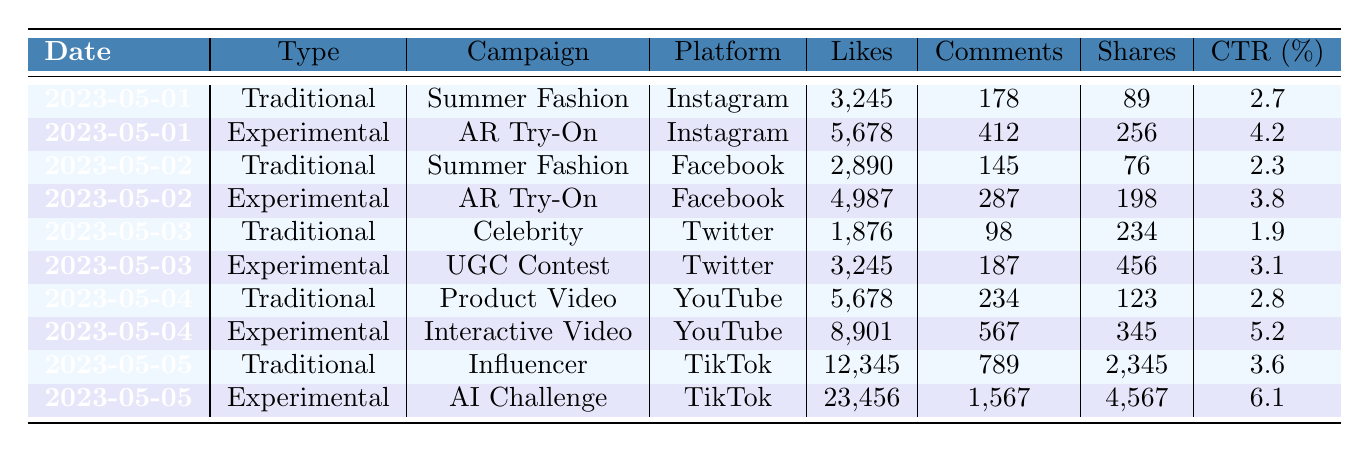What was the highest number of likes on any campaign? Looking through the likes for each campaign, the highest value is 23,456 from the campaign "AI-Generated Content Challenge" on TikTok.
Answer: 23,456 Which campaign received the most comments on May 5th? On May 5th, the "AI-Generated Content Challenge" received 1,567 comments, which is higher than any other campaign on that day.
Answer: AI-Generated Content Challenge What is the average click-through rate for traditional campaigns? The click-through rates for traditional campaigns are 2.7, 2.3, 1.9, 2.8, and 3.6. Summing these gives 13.3 and dividing by 5 gives an average of 2.66.
Answer: 2.66 Did the "Interactive Shoppable Video" campaign have a better engagement than the "Product Showcase Video"? The "Interactive Shoppable Video" had more likes (8,901 vs. 5,678), comments (567 vs. 234), shares (345 vs. 123), and a higher click-through rate (5.2% vs. 2.8%). Thus, it had better engagement.
Answer: Yes What was the total number of shares across all experimental campaigns? Adding up the shares gives 256 + 198 + 456 + 345 + 4,567 = 5,822 shares from experimental campaigns.
Answer: 5,822 Which platform had the lowest average engagement (likes + comments + shares) for traditional campaigns? For traditional campaigns, the total engagement (likes + comments + shares) on Instagram is 3,245 + 178 + 89 = 3,512; on Facebook is 2,890 + 145 + 76 = 3,111; on Twitter is 1,876 + 98 + 234 = 2,208; and on YouTube is 5,678 + 234 + 123 = 6,035. The lowest is 2,208 on Twitter.
Answer: Twitter Is there a campaign that both had the highest number of shares and the highest click-through rate? The "AI-Generated Content Challenge" had the highest shares of 4,567 and also a high click-through rate of 6.1%, making it the only campaign with both distinctions in the given data.
Answer: Yes What is the difference in total likes between traditional and experimental campaigns? Adding traditional likes gives 3,245 + 2,890 + 1,876 + 5,678 + 12,345 = 26,034; experimental likes give 5,678 + 4,987 + 3,245 + 8,901 + 23,456 = 46,267. The difference is 46,267 - 26,034 = 20,233.
Answer: 20,233 Which campaign type had a higher average number of comments, traditional or experimental? Traditional comments total to 178 + 145 + 98 + 234 + 789 = 1,444 (average = 1,444/5 = 288.8). Experimental comments total to 412 + 287 + 187 + 567 + 1,567 = 3,020 (average = 3,020/5 = 604). Experimental has a higher average.
Answer: Experimental On which date did the traditional campaign "Celebrity Endorsement" run? The "Celebrity Endorsement" campaign ran on May 3rd according to the data presented.
Answer: May 3rd 